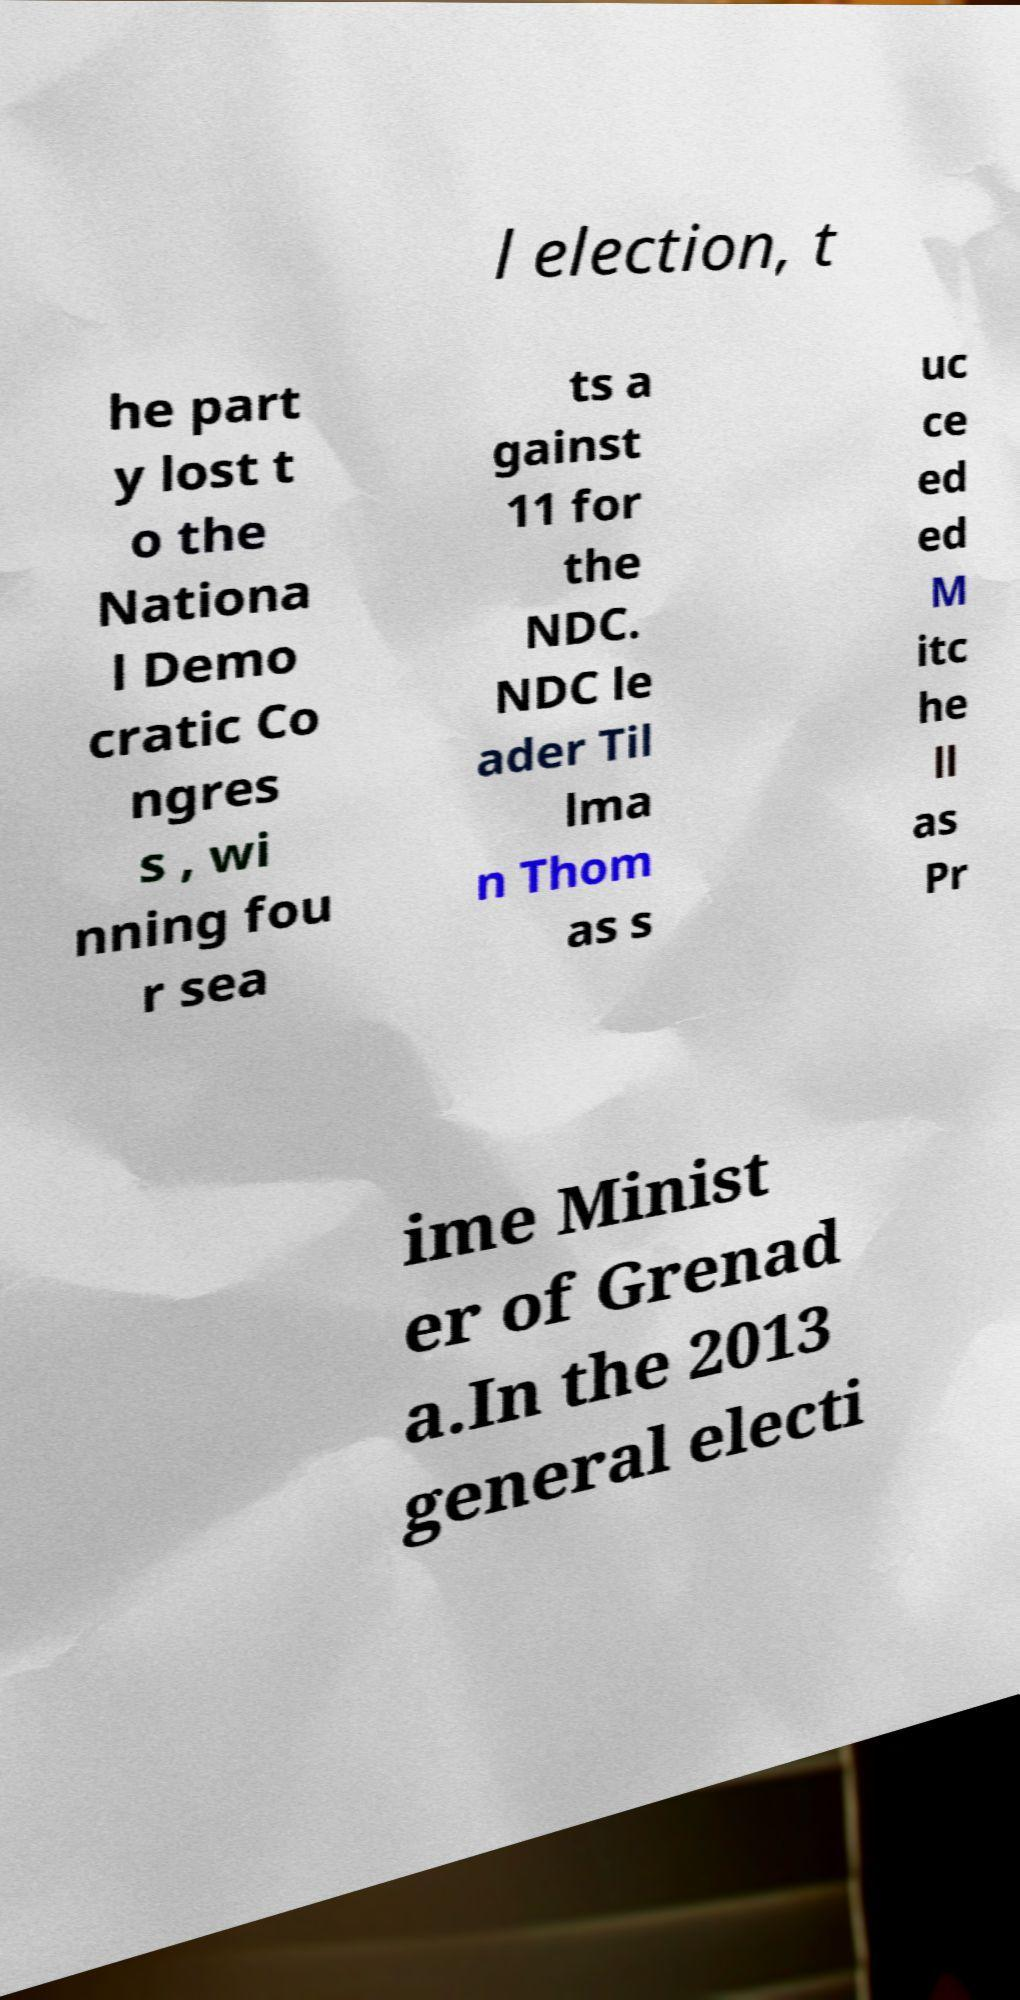I need the written content from this picture converted into text. Can you do that? l election, t he part y lost t o the Nationa l Demo cratic Co ngres s , wi nning fou r sea ts a gainst 11 for the NDC. NDC le ader Til lma n Thom as s uc ce ed ed M itc he ll as Pr ime Minist er of Grenad a.In the 2013 general electi 